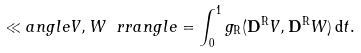<formula> <loc_0><loc_0><loc_500><loc_500>\ll a n g l e V , W \ r r a n g l e = \int _ { 0 } ^ { 1 } g _ { \mathrm R } ( \mathbf D ^ { \mathrm R } V , \mathbf D ^ { \mathrm R } W ) \, \mathrm d t .</formula> 